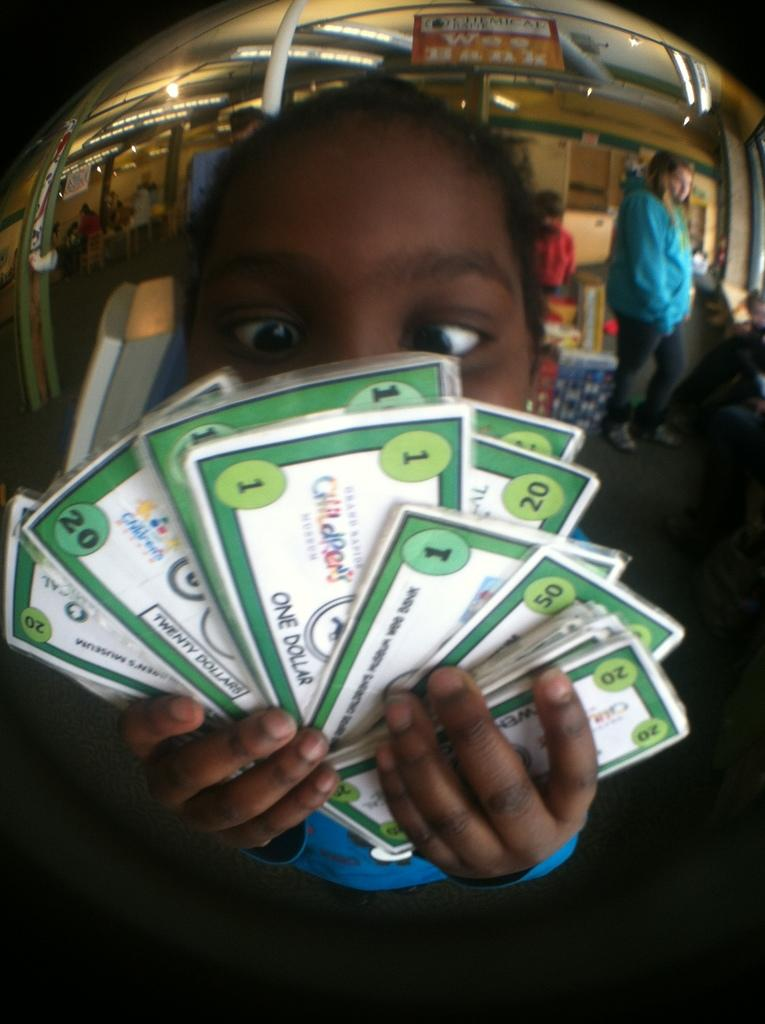What is the main subject in the foreground of the image? There is a person in the foreground of the image. What is the person holding in the image? The person is holding cash. Can you describe the background of the image? There are people visible in the background of the image. What type of crown is the person wearing in the image? There is no crown visible in the image; the person is holding cash. What type of market can be seen in the background of the image? There is no market present in the image; the background only shows people. 